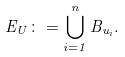Convert formula to latex. <formula><loc_0><loc_0><loc_500><loc_500>E _ { U } \colon = \bigcup _ { i = 1 } ^ { n } B _ { u _ { i } } .</formula> 